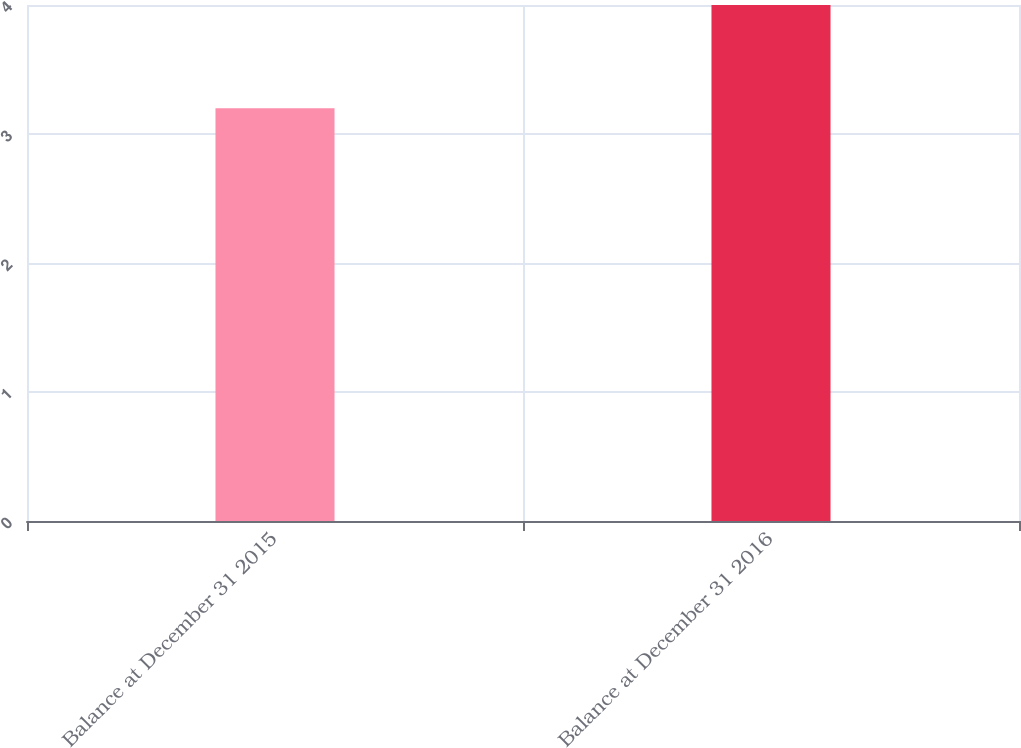Convert chart to OTSL. <chart><loc_0><loc_0><loc_500><loc_500><bar_chart><fcel>Balance at December 31 2015<fcel>Balance at December 31 2016<nl><fcel>3.2<fcel>4<nl></chart> 